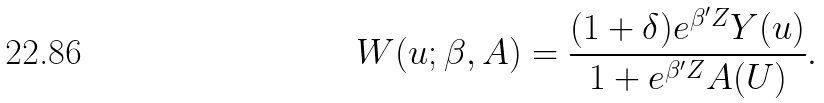Convert formula to latex. <formula><loc_0><loc_0><loc_500><loc_500>W ( u ; \beta , A ) = \frac { ( 1 + \delta ) e ^ { \beta ^ { \prime } Z } Y ( u ) } { 1 + e ^ { \beta ^ { \prime } Z } A ( U ) } .</formula> 